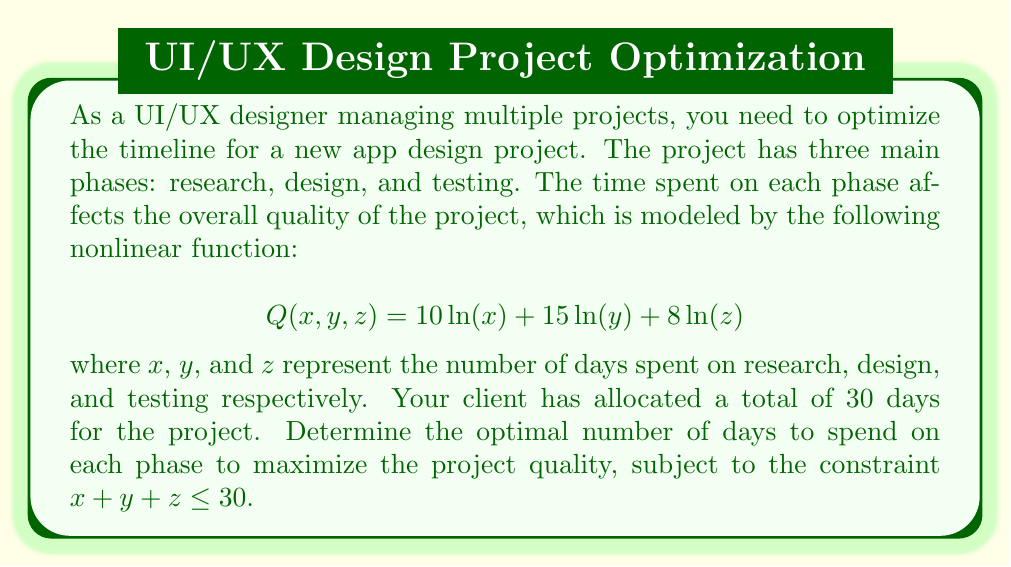Can you answer this question? To solve this nonlinear programming problem, we'll use the method of Lagrange multipliers:

1) Define the Lagrangian function:
   $$L(x, y, z, \lambda) = 10\ln(x) + 15\ln(y) + 8\ln(z) - \lambda(x + y + z - 30)$$

2) Take partial derivatives and set them equal to zero:
   $$\frac{\partial L}{\partial x} = \frac{10}{x} - \lambda = 0$$
   $$\frac{\partial L}{\partial y} = \frac{15}{y} - \lambda = 0$$
   $$\frac{\partial L}{\partial z} = \frac{8}{z} - \lambda = 0$$
   $$\frac{\partial L}{\partial \lambda} = -(x + y + z - 30) = 0$$

3) From the first three equations:
   $$x = \frac{10}{\lambda}, y = \frac{15}{\lambda}, z = \frac{8}{\lambda}$$

4) Substitute these into the fourth equation:
   $$\frac{10}{\lambda} + \frac{15}{\lambda} + \frac{8}{\lambda} = 30$$
   $$\frac{33}{\lambda} = 30$$
   $$\lambda = \frac{33}{30} = 1.1$$

5) Now we can solve for x, y, and z:
   $$x = \frac{10}{1.1} \approx 9.09$$
   $$y = \frac{15}{1.1} \approx 13.64$$
   $$z = \frac{8}{1.1} \approx 7.27$$

6) Rounding to the nearest whole number of days:
   x = 9 days (research)
   y = 14 days (design)
   z = 7 days (testing)

This allocation maximizes the project quality while staying within the 30-day constraint.
Answer: Research: 9 days, Design: 14 days, Testing: 7 days 